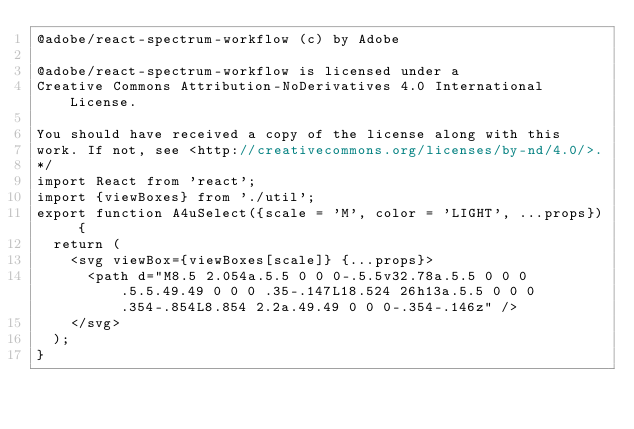<code> <loc_0><loc_0><loc_500><loc_500><_JavaScript_>@adobe/react-spectrum-workflow (c) by Adobe

@adobe/react-spectrum-workflow is licensed under a
Creative Commons Attribution-NoDerivatives 4.0 International License.

You should have received a copy of the license along with this
work. If not, see <http://creativecommons.org/licenses/by-nd/4.0/>.
*/
import React from 'react';
import {viewBoxes} from './util';
export function A4uSelect({scale = 'M', color = 'LIGHT', ...props}) {
  return (
    <svg viewBox={viewBoxes[scale]} {...props}>
      <path d="M8.5 2.054a.5.5 0 0 0-.5.5v32.78a.5.5 0 0 0 .5.5.49.49 0 0 0 .35-.147L18.524 26h13a.5.5 0 0 0 .354-.854L8.854 2.2a.49.49 0 0 0-.354-.146z" />
    </svg>
  );
}
</code> 